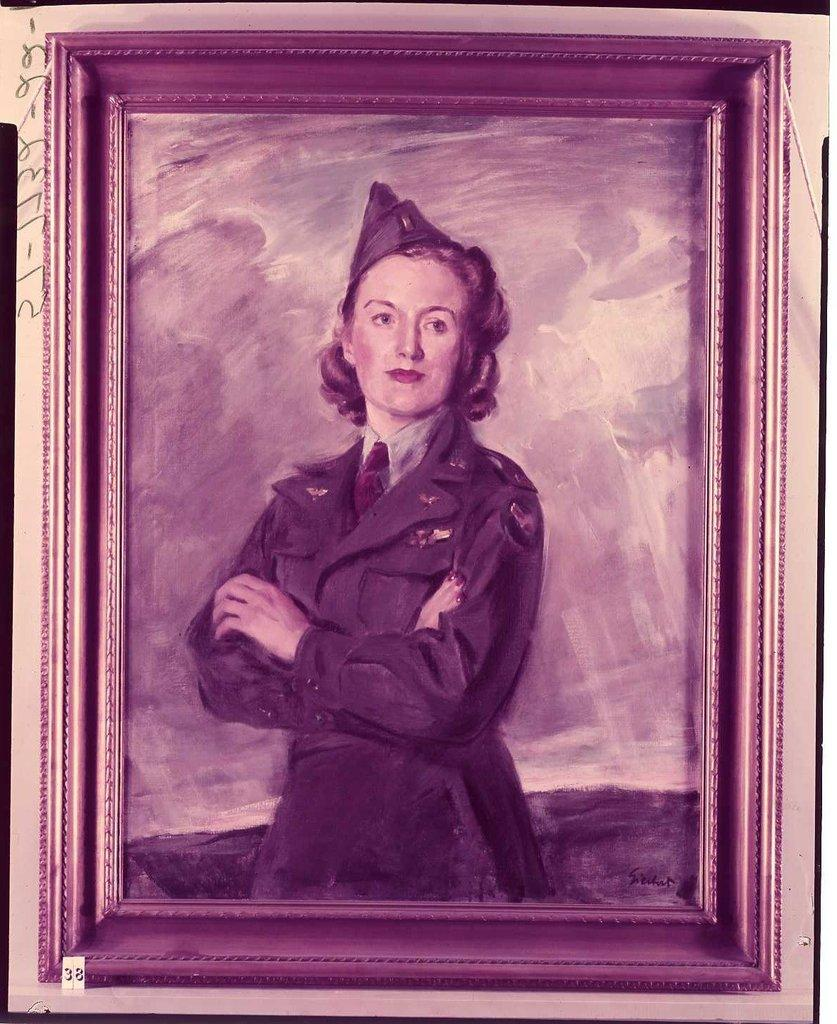What is the main subject of the painting in the image? The painting depicts a woman. What is the painting surrounded by in the image? The painting has a frame in the image. What can be seen on the left side of the image? There is text on the left side of the image. Is there any additional information about the painting visible in the image? Yes, there is a tag visible at the bottom of the image. Can you see any cannons in the painting? There are no cannons visible in the painting or the image. Are there any fairies flying around the woman in the painting? There are no fairies depicted in the painting or the image. 